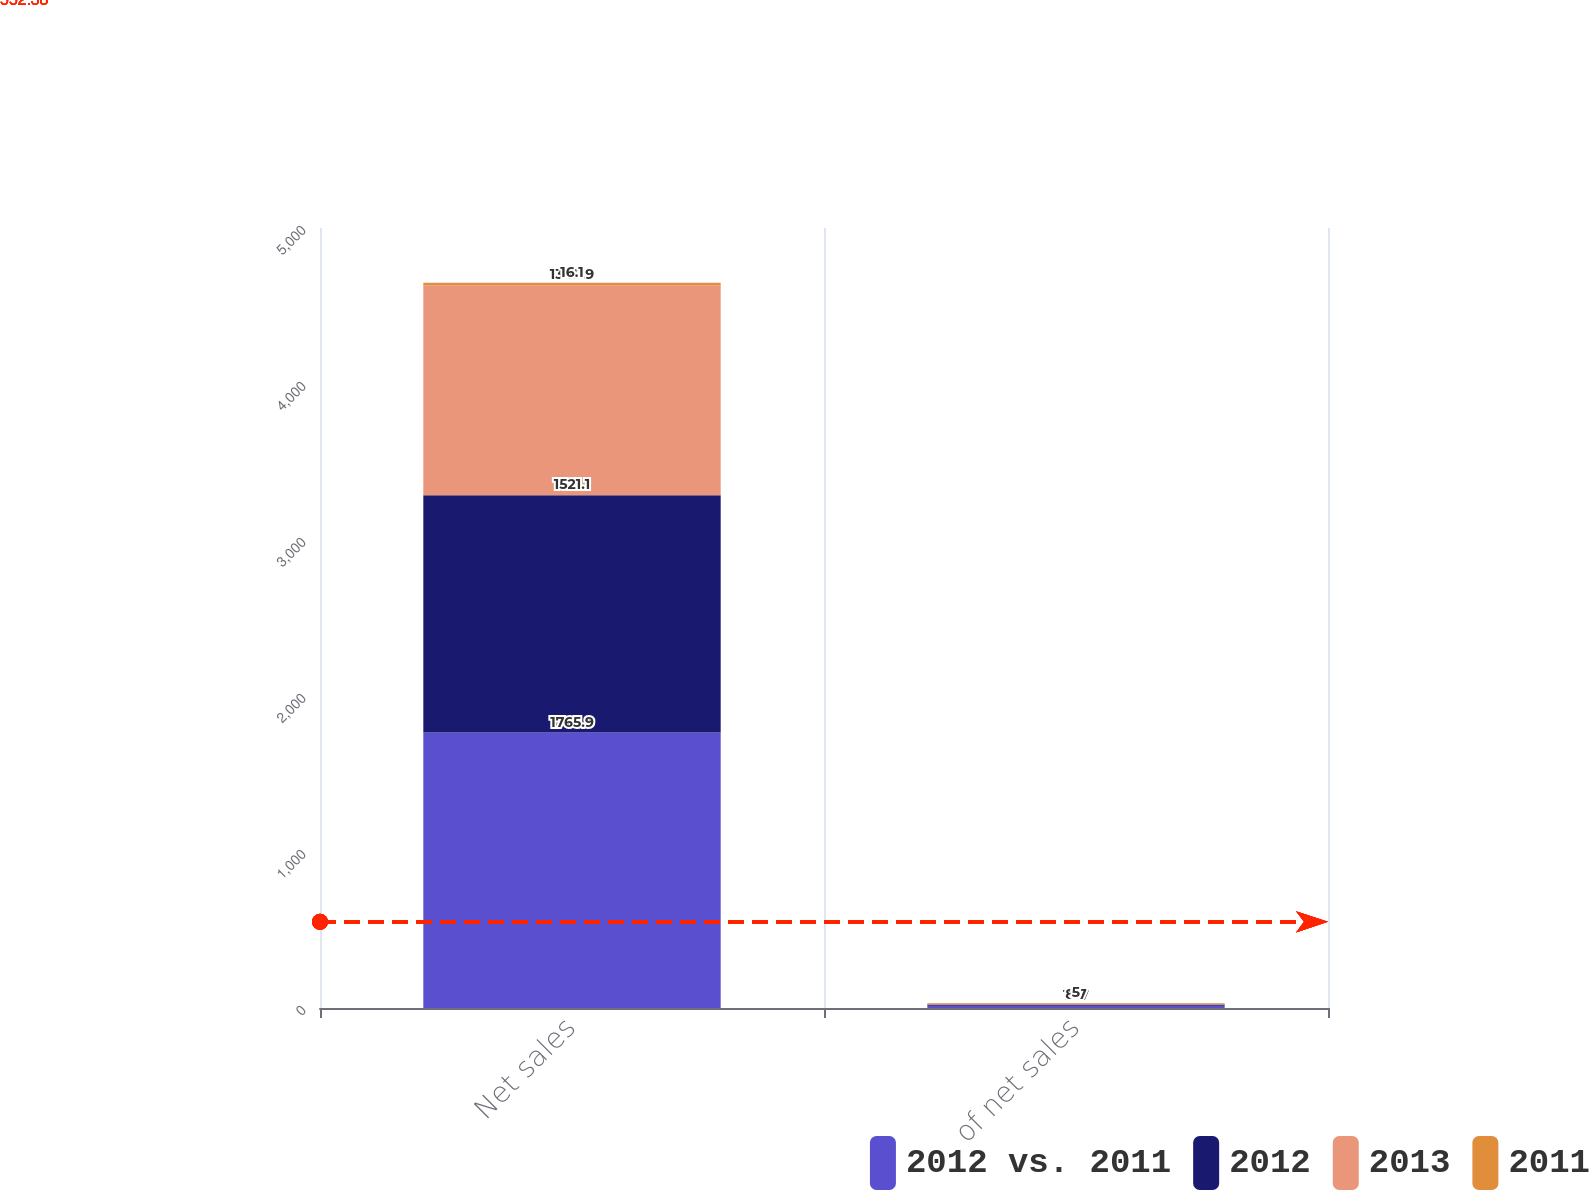<chart> <loc_0><loc_0><loc_500><loc_500><stacked_bar_chart><ecel><fcel>Net sales<fcel>of net sales<nl><fcel>2012 vs. 2011<fcel>1765.9<fcel>13.7<nl><fcel>2012<fcel>1521.1<fcel>8.7<nl><fcel>2013<fcel>1345.9<fcel>3<nl><fcel>2011<fcel>16.1<fcel>5<nl></chart> 